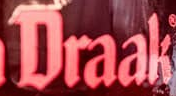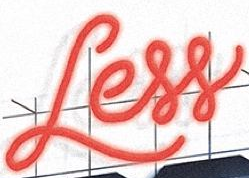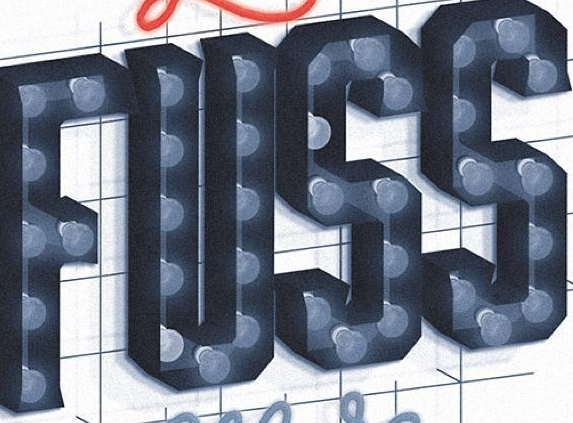What text appears in these images from left to right, separated by a semicolon? Draak; Less; FUSS 